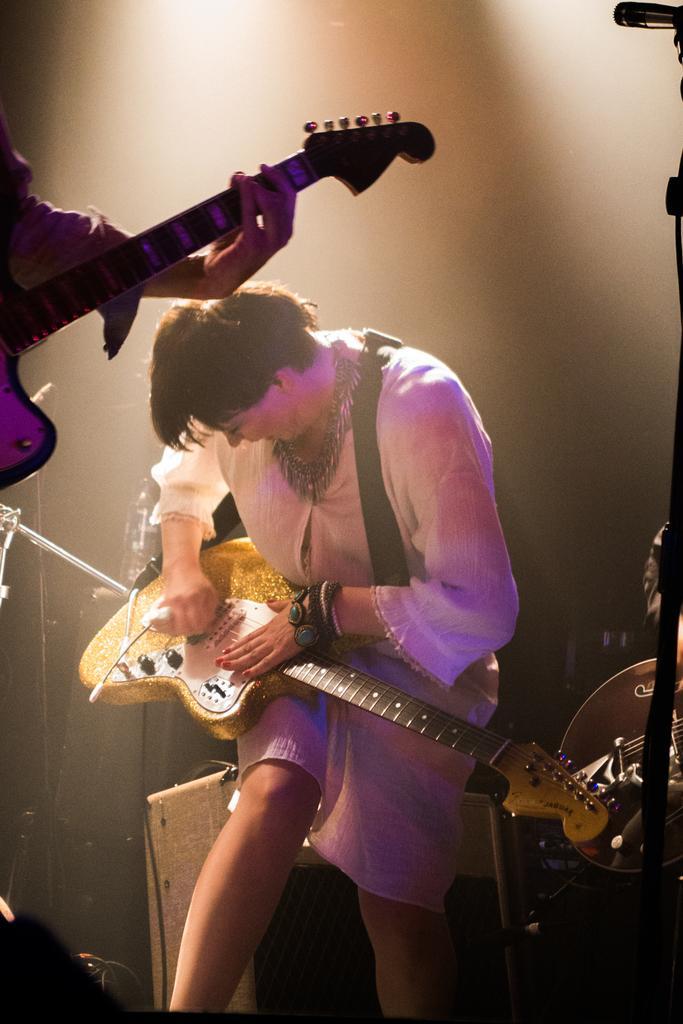Please provide a concise description of this image. This woman wore white dress and playing a guitar. Backside of this woman there is a box. Other person is also holding a guitar. 